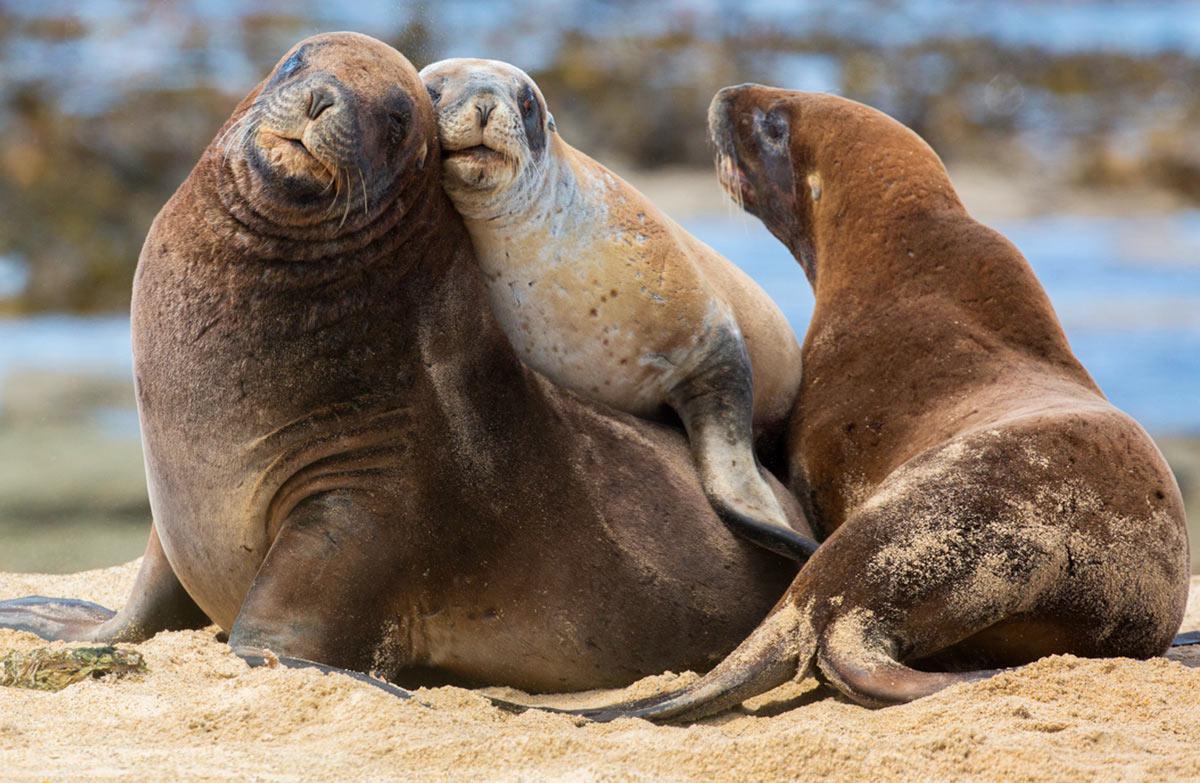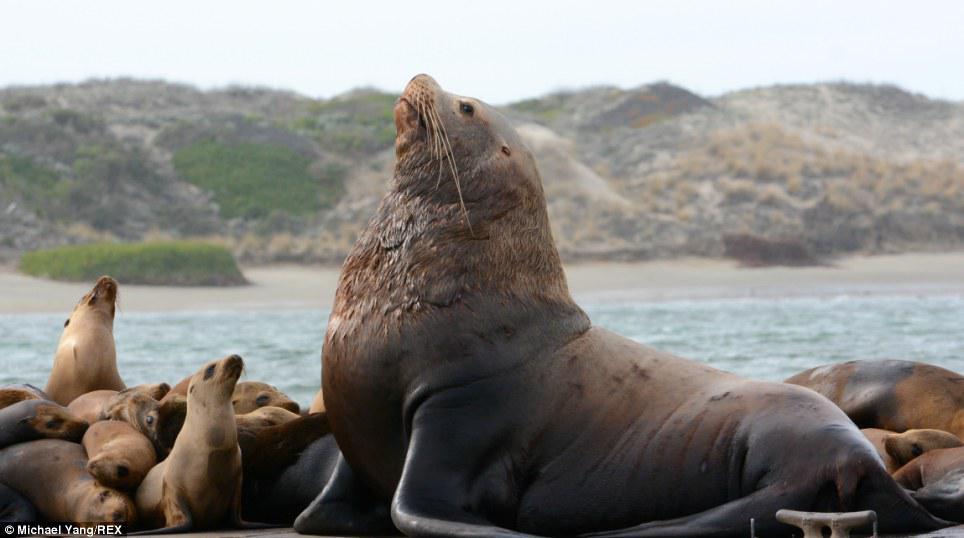The first image is the image on the left, the second image is the image on the right. Considering the images on both sides, is "There is a watery area behind the animals" valid? Answer yes or no. Yes. The first image is the image on the left, the second image is the image on the right. For the images displayed, is the sentence "An image shows one large seal with raised head amidst multiple smaller seals." factually correct? Answer yes or no. Yes. 